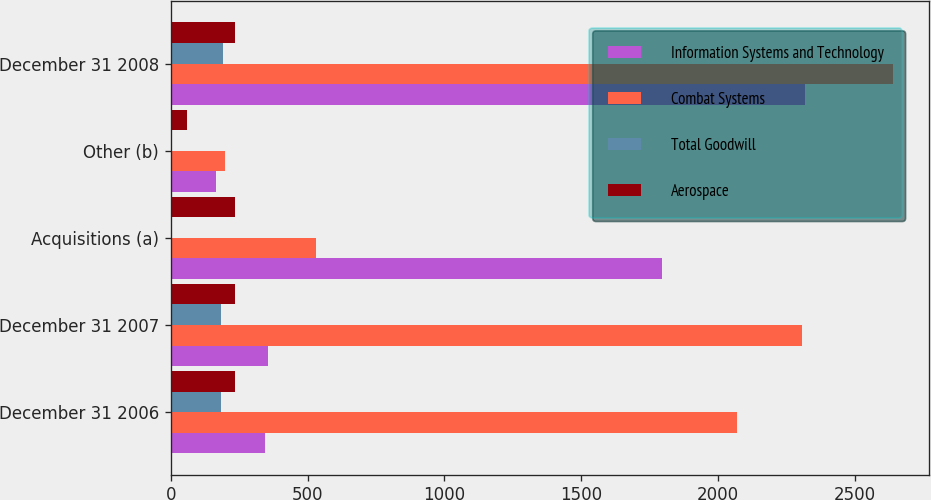<chart> <loc_0><loc_0><loc_500><loc_500><stacked_bar_chart><ecel><fcel>December 31 2006<fcel>December 31 2007<fcel>Acquisitions (a)<fcel>Other (b)<fcel>December 31 2008<nl><fcel>Information Systems and Technology<fcel>343<fcel>355<fcel>1795<fcel>166<fcel>2316<nl><fcel>Combat Systems<fcel>2069<fcel>2308<fcel>529<fcel>199<fcel>2638<nl><fcel>Total Goodwill<fcel>185<fcel>185<fcel>6<fcel>1<fcel>192<nl><fcel>Aerospace<fcel>234<fcel>234<fcel>234<fcel>61<fcel>234<nl></chart> 